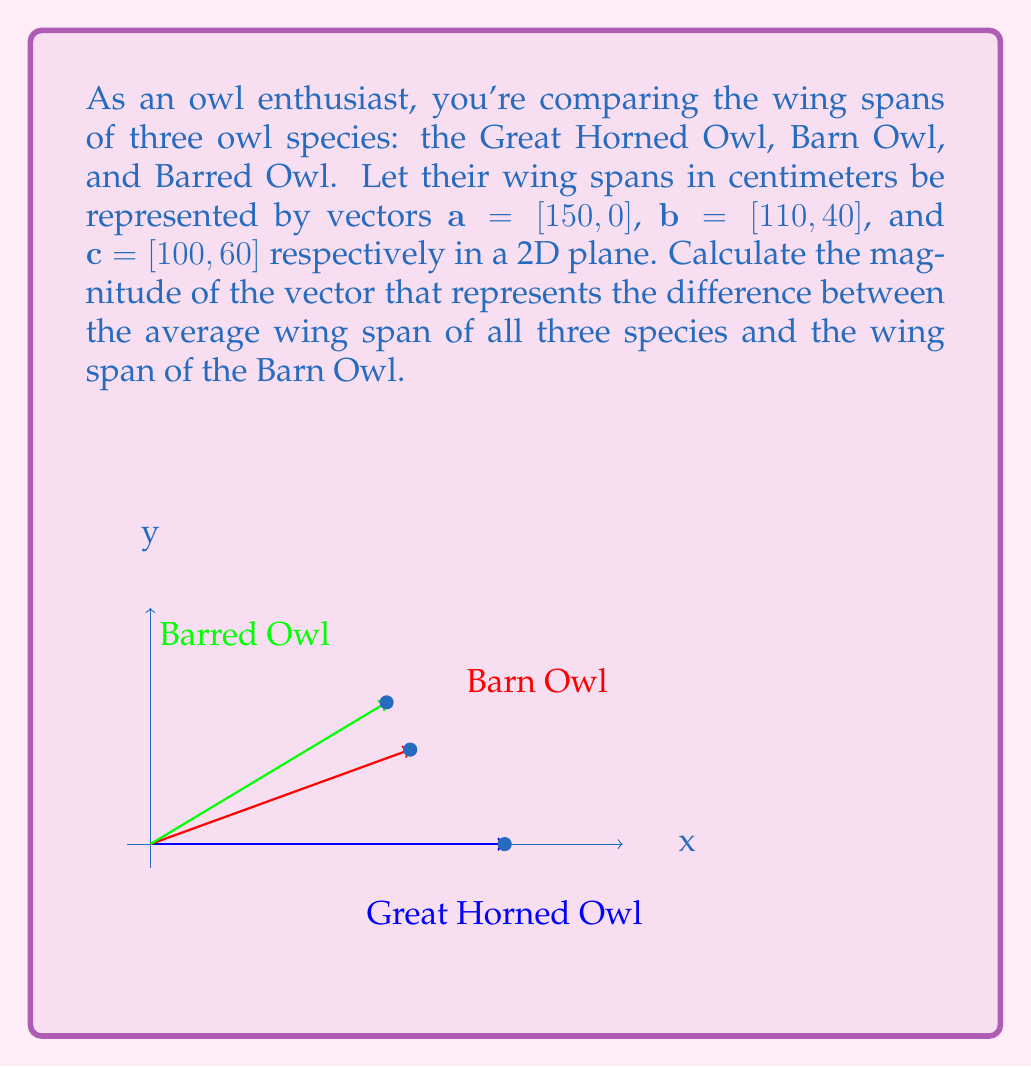Show me your answer to this math problem. Let's approach this step-by-step:

1) First, we need to calculate the average wing span vector:
   $$\mathbf{avg} = \frac{\mathbf{a} + \mathbf{b} + \mathbf{c}}{3}$$

2) Calculate the sum of the vectors:
   $$\mathbf{a} + \mathbf{b} + \mathbf{c} = [150, 0] + [110, 40] + [100, 60] = [360, 100]$$

3) Divide by 3 to get the average:
   $$\mathbf{avg} = [\frac{360}{3}, \frac{100}{3}] = [120, \frac{100}{3}]$$

4) Now, we need to find the difference between this average and the Barn Owl's wing span:
   $$\mathbf{diff} = \mathbf{avg} - \mathbf{b} = [120, \frac{100}{3}] - [110, 40]$$

5) Simplify:
   $$\mathbf{diff} = [10, \frac{100}{3} - 40] = [10, -\frac{20}{3}]$$

6) To find the magnitude of this difference vector, we use the Pythagorean theorem:
   $$|\mathbf{diff}| = \sqrt{10^2 + (-\frac{20}{3})^2}$$

7) Simplify under the square root:
   $$|\mathbf{diff}| = \sqrt{100 + \frac{400}{9}} = \sqrt{\frac{900 + 400}{9}} = \sqrt{\frac{1300}{9}}$$

8) Simplify the fraction under the square root:
   $$|\mathbf{diff}| = \frac{\sqrt{1300}}{3} \approx 12.02$$

Therefore, the magnitude of the difference vector is $\frac{\sqrt{1300}}{3}$ cm.
Answer: $\frac{\sqrt{1300}}{3}$ cm 